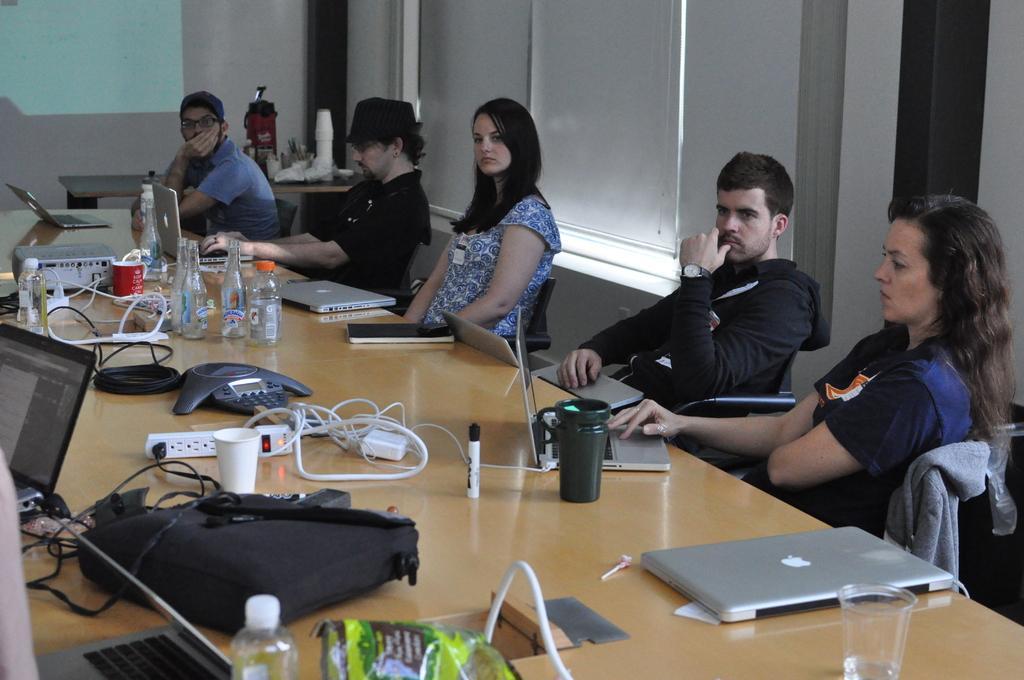Can you describe this image briefly? In this picture there are some people sitting in the chairs around the table on which a bags, spike plugs, laptops, cups and water bottles were placed. In the background there is a projector display screen on the wall. 